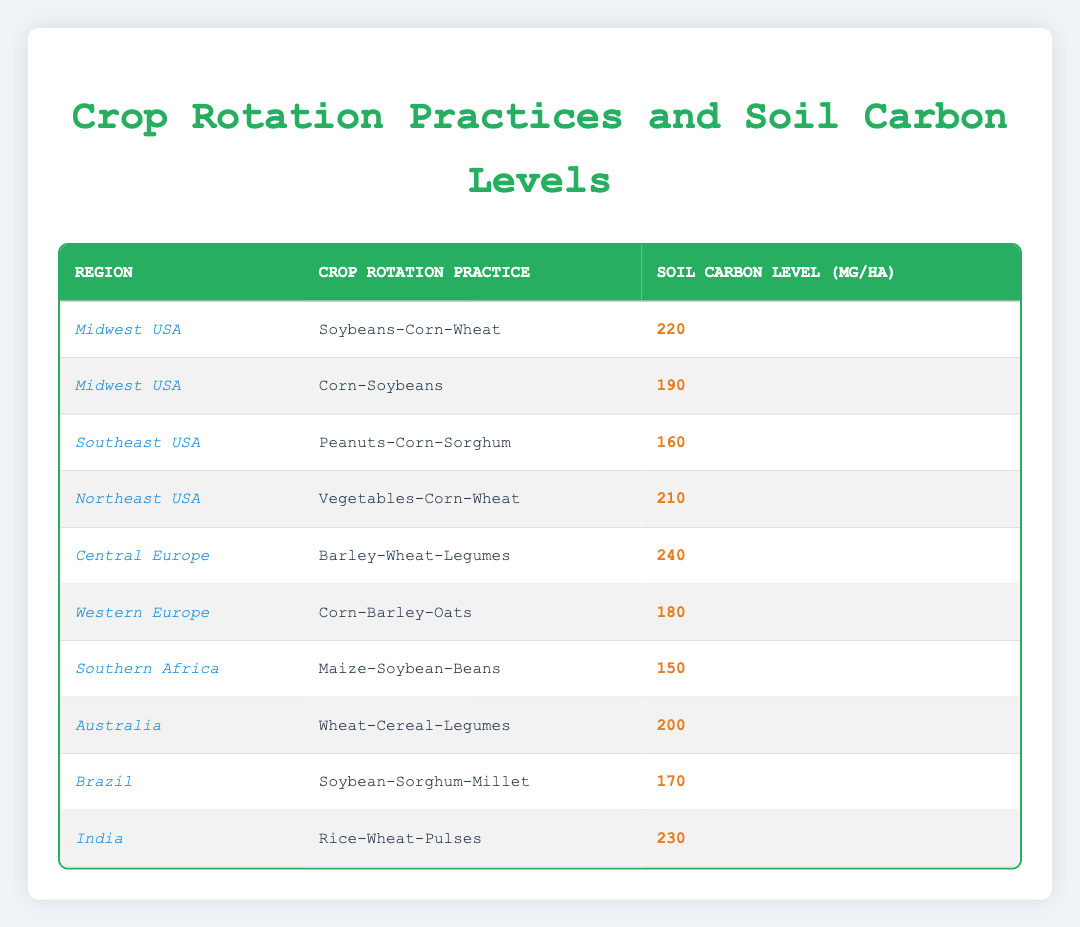What is the soil carbon level in Central Europe for the crop rotation practice Barley-Wheat-Legumes? The table lists the soil carbon level for Central Europe under the crop rotation practice Barley-Wheat-Legumes, which is 240 mg/ha.
Answer: 240 mg/ha Which region has the highest soil carbon level? By comparing the soil carbon levels across all regions listed, Central Europe has the highest level at 240 mg/ha.
Answer: Central Europe What is the average soil carbon level for regions in the USA? The USA regions are Midwest, Southeast, and Northeast. Their soil carbon levels are 220, 190, and 210 mg/ha respectively. The sum is (220 + 190 + 210) = 620 mg/ha, and dividing by 3 gives an average of 620/3 = approximately 206.67 mg/ha.
Answer: Approximately 206.67 mg/ha Is the soil carbon level for the crop rotation practice Soybeans-Corn-Wheat higher than that for Corn-Soybeans in the Midwest USA? The soil carbon level for Soybeans-Corn-Wheat is 220 mg/ha while for Corn-Soybeans it is 190 mg/ha. Since 220 mg/ha is greater than 190 mg/ha, the statement is true.
Answer: Yes Which crop rotation practice in India has a higher soil carbon level compared to the practice in Southern Africa? In India, the soil carbon level for Rice-Wheat-Pulses is 230 mg/ha, and in Southern Africa, the level for Maize-Soybean-Beans is 150 mg/ha. Since 230 mg/ha is greater than 150 mg/ha, India's practice has a higher level.
Answer: Yes What is the difference in soil carbon levels between the highest and lowest practices listed? The highest soil carbon level is 240 mg/ha (Central Europe, Barley-Wheat-Legumes) and the lowest is 150 mg/ha (Southern Africa, Maize-Soybean-Beans). The difference is calculated as 240 - 150 = 90 mg/ha.
Answer: 90 mg/ha Which crop rotation practice has the lowest soil carbon level in the table? Comparing all practices, the lowest soil carbon level is Maize-Soybean-Beans from Southern Africa at 150 mg/ha.
Answer: Maize-Soybean-Beans How does the soil carbon level of Wheat-Cereal-Legumes in Australia compare to that in Brazil for Soybean-Sorghum-Millet? The soil carbon level for Wheat-Cereal-Legumes in Australia is 200 mg/ha, while for Soybean-Sorghum-Millet in Brazil it is 170 mg/ha. Since 200 mg/ha is greater than 170 mg/ha, the practice in Australia has a higher level.
Answer: Yes What is the total soil carbon level for all crop rotation practices listed? The sum of soil carbon levels for all regions can be calculated as follows: 220 + 190 + 160 + 210 + 240 + 180 + 150 + 200 + 170 + 230 = 1950 mg/ha.
Answer: 1950 mg/ha 